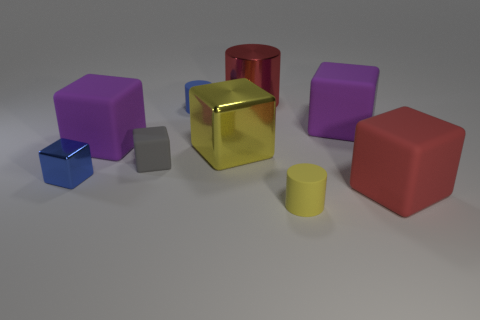There is a big shiny cylinder; does it have the same color as the big rubber cube that is in front of the big metallic block?
Your response must be concise. Yes. What is the size of the matte cylinder that is the same color as the tiny metal thing?
Your answer should be compact. Small. Is there a large rubber block that has the same color as the large cylinder?
Make the answer very short. Yes. What is the shape of the rubber thing that is the same color as the large metal cylinder?
Your answer should be very brief. Cube. Do the tiny rubber object in front of the gray matte cube and the large shiny cube have the same color?
Give a very brief answer. Yes. The yellow shiny thing is what size?
Provide a succinct answer. Large. Is the material of the cylinder in front of the small blue cylinder the same as the large yellow block?
Provide a succinct answer. No. How many purple matte objects are there?
Your answer should be compact. 2. How many things are either big blue matte balls or metal blocks?
Offer a very short reply. 2. There is a metal block that is right of the metallic object that is left of the yellow shiny block; what number of big purple blocks are on the left side of it?
Keep it short and to the point. 1. 